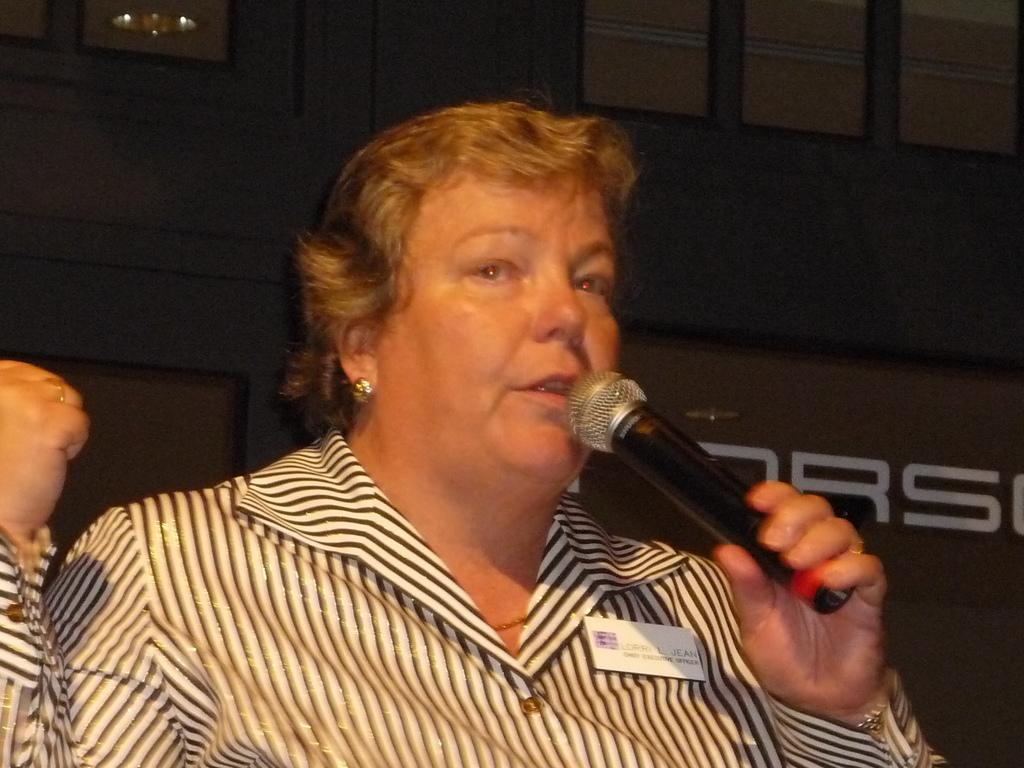Describe this image in one or two sentences. In this image, we can see a woman is holding a microphone and talking. There is a batch on her shirt. Background we can see some text. 